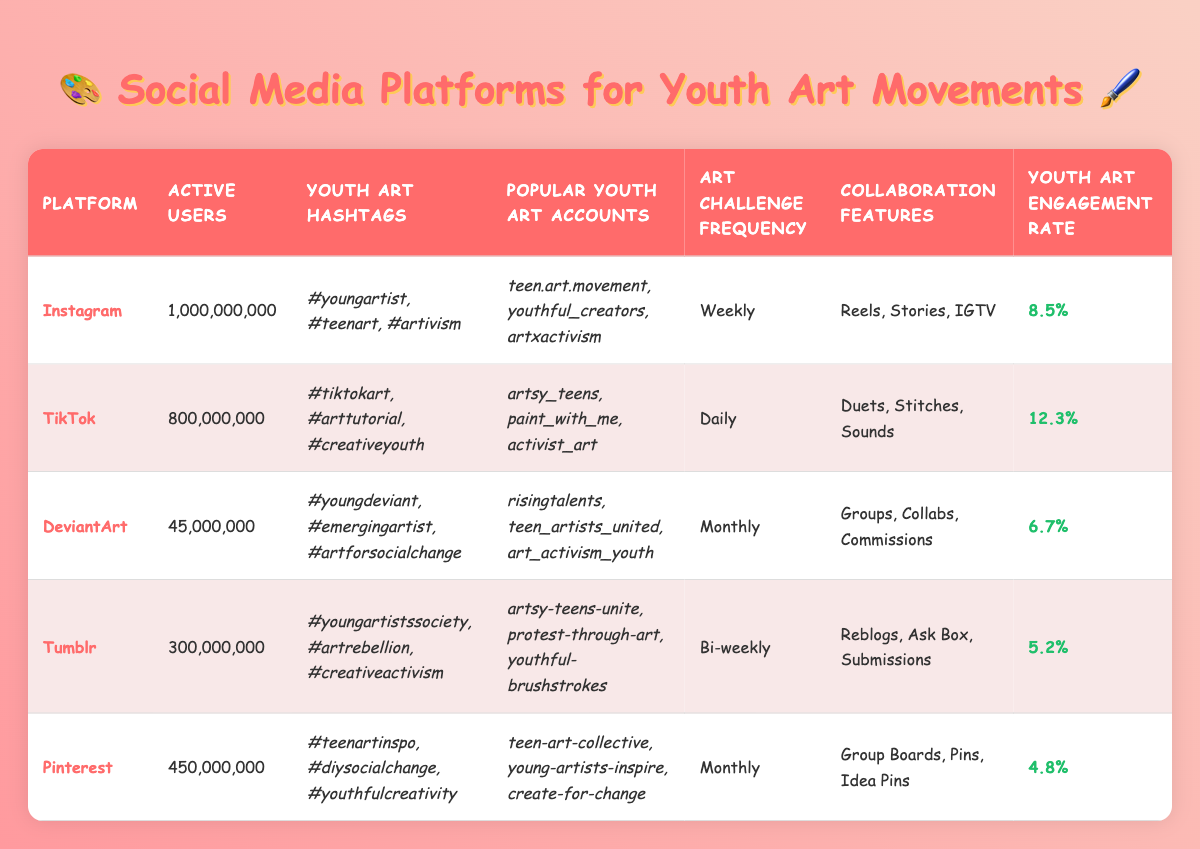What is the engagement rate of TikTok? The engagement rate is listed in the table under the "Youth Art Engagement Rate" column for TikTok, which is specified as 12.3%.
Answer: 12.3% Which platform has the highest number of active users? By examining the "Active Users" column, Instagram has the highest number of active users at 1,000,000,000.
Answer: Instagram What is the frequency of art challenges on DeviantArt? The "Art Challenge Frequency" for DeviantArt is stated as "Monthly" in the corresponding column.
Answer: Monthly Which platform has the lowest youth art engagement rate and what is that rate? The engagement rates listed show Pinterest has the lowest rate at 4.8%, the value in the "Youth Art Engagement Rate" column.
Answer: 4.8% How many times more active users does Instagram have compared to DeviantArt? To find the difference, subtract 45,000,000 (DeviantArt's active users) from 1,000,000,000 (Instagram's active users) to get 955,000,000. To find how many times more: 1,000,000,000 / 45,000,000 ≈ 22.22. Instagram has approximately 22.22 times more active users than DeviantArt.
Answer: Approximately 22.22 times Is it true that Tumblr has an art challenge frequency that is more frequent than once a month? Comparing Tumblr's "Art Challenge Frequency," which is "Bi-weekly," to "Monthly," it shows that Bi-weekly occurs more than once a month. Hence, the statement is true.
Answer: Yes Which platform has collaboration features that include "Duets," and how many active users does it have? The "Collaboration Features" section for TikTok lists "Duets," and looking at the "Active Users" column reveals TikTok has 800,000,000 active users.
Answer: 800,000,000 What is the total of active users for Pinterest and DeviantArt combined? To find this, add the active users of Pinterest (450,000,000) to those of DeviantArt (45,000,000): 450,000,000 + 45,000,000 = 495,000,000. Thus, the total is 495,000,000.
Answer: 495,000,000 Which platform has more youth art hashtags, TikTok or DeviantArt? TikTok has three youth art hashtags (#tiktokart, #arttutorial, #creativeyouth) while DeviantArt has three youth art hashtags (#youngdeviant, #emergingartist, #artforsocialchange). Both have the same number.
Answer: They have the same number 